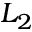Convert formula to latex. <formula><loc_0><loc_0><loc_500><loc_500>L _ { 2 }</formula> 